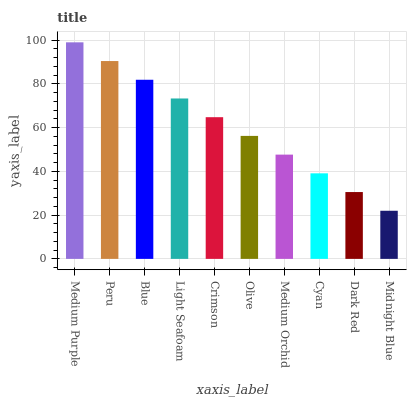Is Midnight Blue the minimum?
Answer yes or no. Yes. Is Medium Purple the maximum?
Answer yes or no. Yes. Is Peru the minimum?
Answer yes or no. No. Is Peru the maximum?
Answer yes or no. No. Is Medium Purple greater than Peru?
Answer yes or no. Yes. Is Peru less than Medium Purple?
Answer yes or no. Yes. Is Peru greater than Medium Purple?
Answer yes or no. No. Is Medium Purple less than Peru?
Answer yes or no. No. Is Crimson the high median?
Answer yes or no. Yes. Is Olive the low median?
Answer yes or no. Yes. Is Midnight Blue the high median?
Answer yes or no. No. Is Midnight Blue the low median?
Answer yes or no. No. 